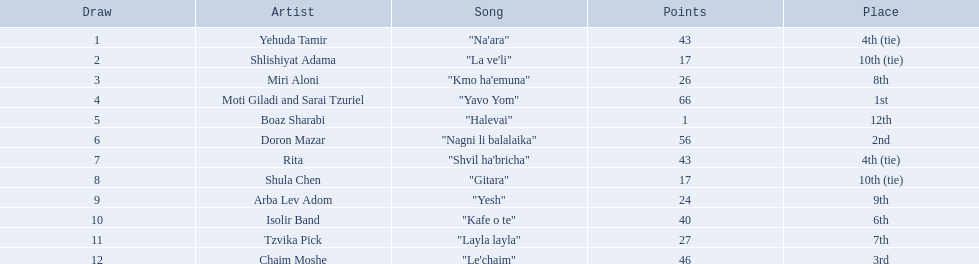Who are all the creators? Yehuda Tamir, Shlishiyat Adama, Miri Aloni, Moti Giladi and Sarai Tzuriel, Boaz Sharabi, Doron Mazar, Rita, Shula Chen, Arba Lev Adom, Isolir Band, Tzvika Pick, Chaim Moshe. How many points did each obtain? 43, 17, 26, 66, 1, 56, 43, 17, 24, 40, 27, 46. And which creator had the smallest number of points? Boaz Sharabi. 